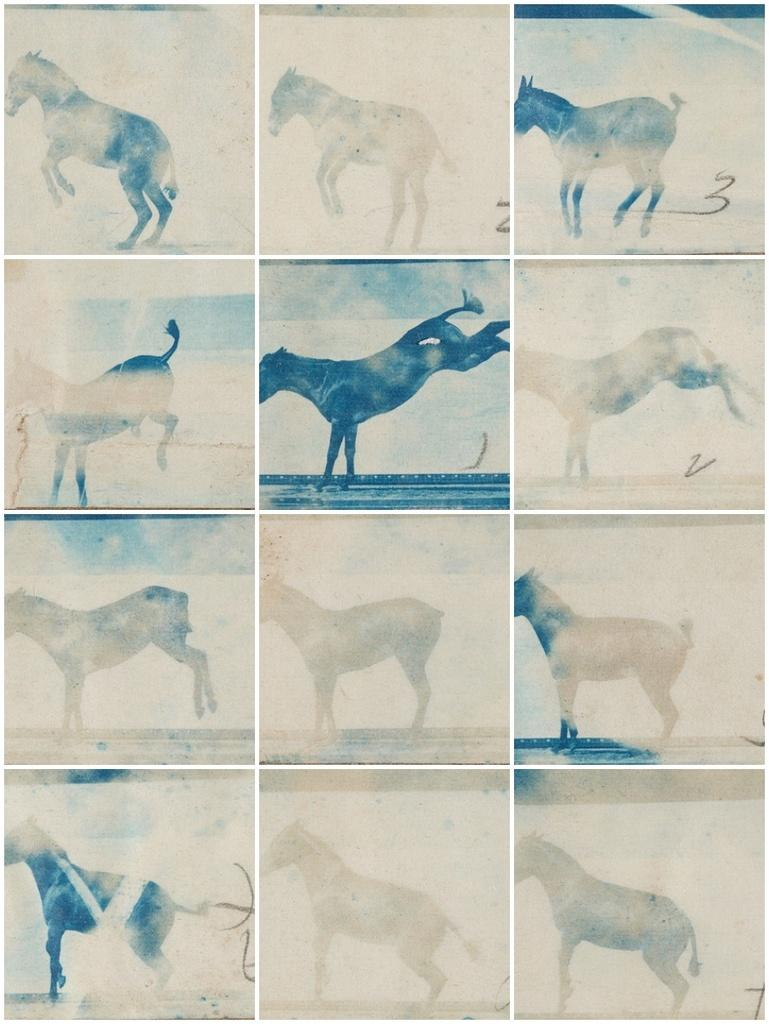What type of image is shown in the picture? The image is a collage. What subject is featured in the collage? The collage contains different poses of a horse. What type of edge is visible on the credit card in the image? There is no credit card present in the image; it is a collage featuring different poses of a horse. How does the horse's afterthought appear in the image? There is no indication of the horse's afterthought in the image, as it is a collage of different poses of the horse. 